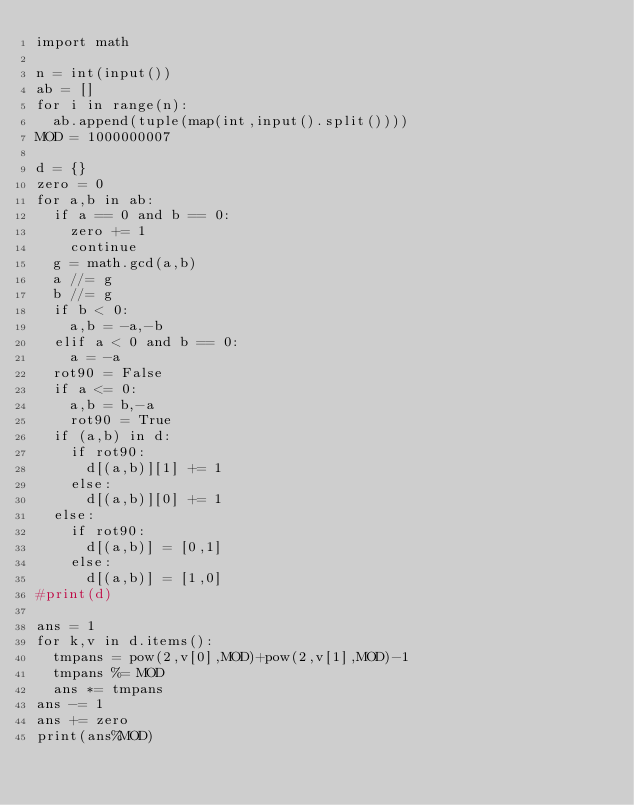<code> <loc_0><loc_0><loc_500><loc_500><_Python_>import math

n = int(input())
ab = []
for i in range(n):
  ab.append(tuple(map(int,input().split())))
MOD = 1000000007

d = {}
zero = 0
for a,b in ab:
  if a == 0 and b == 0:
    zero += 1
    continue
  g = math.gcd(a,b)
  a //= g
  b //= g
  if b < 0:
    a,b = -a,-b
  elif a < 0 and b == 0:
    a = -a
  rot90 = False
  if a <= 0:
    a,b = b,-a
    rot90 = True
  if (a,b) in d:
    if rot90:
      d[(a,b)][1] += 1
    else:
      d[(a,b)][0] += 1
  else:
    if rot90:
      d[(a,b)] = [0,1]
    else:
      d[(a,b)] = [1,0]
#print(d)

ans = 1
for k,v in d.items():
  tmpans = pow(2,v[0],MOD)+pow(2,v[1],MOD)-1
  tmpans %= MOD
  ans *= tmpans
ans -= 1
ans += zero
print(ans%MOD)</code> 